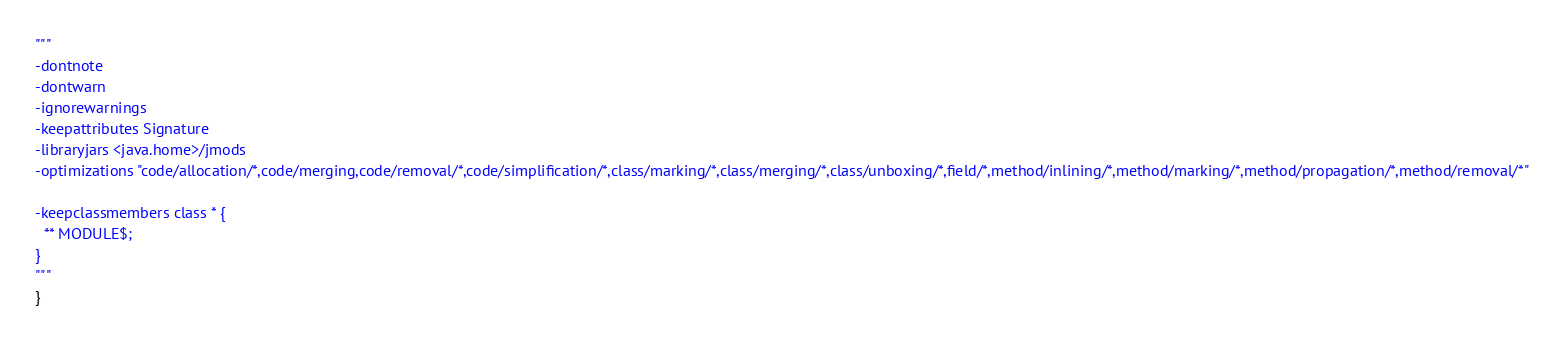<code> <loc_0><loc_0><loc_500><loc_500><_Scala_>"""
-dontnote
-dontwarn
-ignorewarnings
-keepattributes Signature
-libraryjars <java.home>/jmods
-optimizations "code/allocation/*,code/merging,code/removal/*,code/simplification/*,class/marking/*,class/merging/*,class/unboxing/*,field/*,method/inlining/*,method/marking/*,method/propagation/*,method/removal/*"

-keepclassmembers class * {
  ** MODULE$;
}
"""
}
</code> 